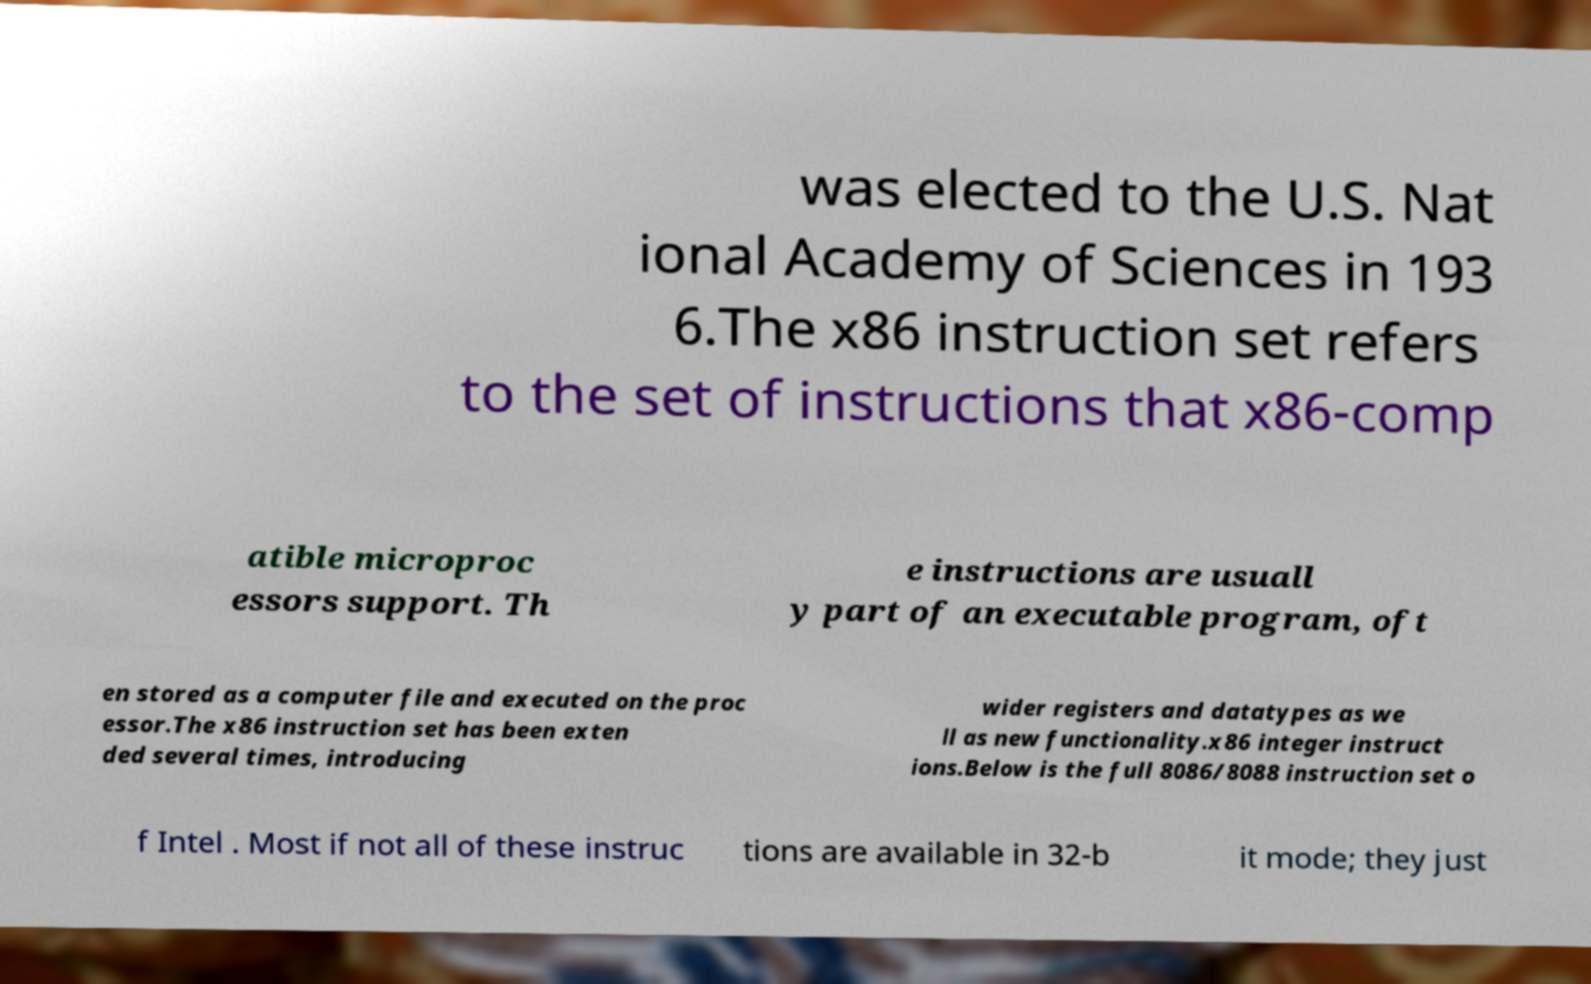What messages or text are displayed in this image? I need them in a readable, typed format. was elected to the U.S. Nat ional Academy of Sciences in 193 6.The x86 instruction set refers to the set of instructions that x86-comp atible microproc essors support. Th e instructions are usuall y part of an executable program, oft en stored as a computer file and executed on the proc essor.The x86 instruction set has been exten ded several times, introducing wider registers and datatypes as we ll as new functionality.x86 integer instruct ions.Below is the full 8086/8088 instruction set o f Intel . Most if not all of these instruc tions are available in 32-b it mode; they just 